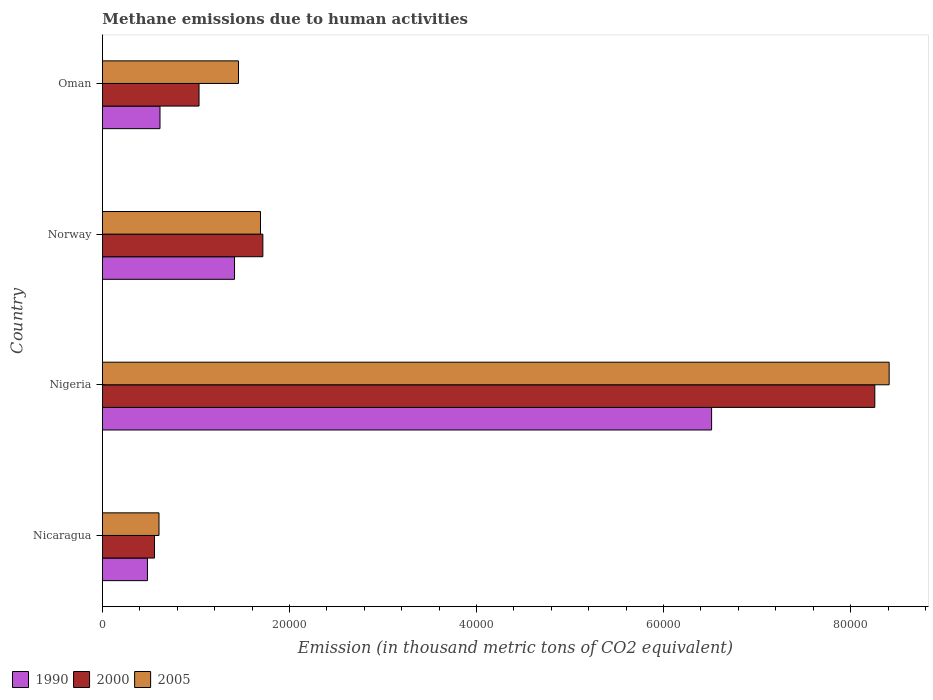How many different coloured bars are there?
Your answer should be compact. 3. How many groups of bars are there?
Give a very brief answer. 4. Are the number of bars per tick equal to the number of legend labels?
Offer a very short reply. Yes. Are the number of bars on each tick of the Y-axis equal?
Your answer should be compact. Yes. How many bars are there on the 2nd tick from the bottom?
Your answer should be compact. 3. What is the label of the 3rd group of bars from the top?
Your response must be concise. Nigeria. In how many cases, is the number of bars for a given country not equal to the number of legend labels?
Provide a short and direct response. 0. What is the amount of methane emitted in 2000 in Oman?
Offer a terse response. 1.03e+04. Across all countries, what is the maximum amount of methane emitted in 1990?
Keep it short and to the point. 6.51e+04. Across all countries, what is the minimum amount of methane emitted in 2000?
Provide a succinct answer. 5565.7. In which country was the amount of methane emitted in 2005 maximum?
Provide a short and direct response. Nigeria. In which country was the amount of methane emitted in 2005 minimum?
Offer a very short reply. Nicaragua. What is the total amount of methane emitted in 2000 in the graph?
Your answer should be very brief. 1.16e+05. What is the difference between the amount of methane emitted in 2005 in Nicaragua and that in Norway?
Make the answer very short. -1.09e+04. What is the difference between the amount of methane emitted in 1990 in Norway and the amount of methane emitted in 2000 in Oman?
Your response must be concise. 3795.6. What is the average amount of methane emitted in 2005 per country?
Offer a terse response. 3.04e+04. What is the difference between the amount of methane emitted in 1990 and amount of methane emitted in 2005 in Nicaragua?
Ensure brevity in your answer.  -1233.7. What is the ratio of the amount of methane emitted in 1990 in Nicaragua to that in Oman?
Your answer should be very brief. 0.78. Is the amount of methane emitted in 2000 in Norway less than that in Oman?
Your response must be concise. No. Is the difference between the amount of methane emitted in 1990 in Norway and Oman greater than the difference between the amount of methane emitted in 2005 in Norway and Oman?
Give a very brief answer. Yes. What is the difference between the highest and the second highest amount of methane emitted in 2000?
Provide a short and direct response. 6.54e+04. What is the difference between the highest and the lowest amount of methane emitted in 2005?
Ensure brevity in your answer.  7.81e+04. In how many countries, is the amount of methane emitted in 1990 greater than the average amount of methane emitted in 1990 taken over all countries?
Provide a succinct answer. 1. Is the sum of the amount of methane emitted in 2005 in Nicaragua and Nigeria greater than the maximum amount of methane emitted in 1990 across all countries?
Provide a succinct answer. Yes. What does the 3rd bar from the top in Oman represents?
Your response must be concise. 1990. What does the 1st bar from the bottom in Norway represents?
Provide a short and direct response. 1990. Are all the bars in the graph horizontal?
Your answer should be very brief. Yes. How many countries are there in the graph?
Keep it short and to the point. 4. Are the values on the major ticks of X-axis written in scientific E-notation?
Offer a very short reply. No. Does the graph contain any zero values?
Keep it short and to the point. No. How many legend labels are there?
Offer a very short reply. 3. How are the legend labels stacked?
Give a very brief answer. Horizontal. What is the title of the graph?
Keep it short and to the point. Methane emissions due to human activities. Does "1998" appear as one of the legend labels in the graph?
Your answer should be very brief. No. What is the label or title of the X-axis?
Offer a very short reply. Emission (in thousand metric tons of CO2 equivalent). What is the Emission (in thousand metric tons of CO2 equivalent) in 1990 in Nicaragua?
Ensure brevity in your answer.  4811.3. What is the Emission (in thousand metric tons of CO2 equivalent) in 2000 in Nicaragua?
Keep it short and to the point. 5565.7. What is the Emission (in thousand metric tons of CO2 equivalent) of 2005 in Nicaragua?
Give a very brief answer. 6045. What is the Emission (in thousand metric tons of CO2 equivalent) in 1990 in Nigeria?
Your answer should be compact. 6.51e+04. What is the Emission (in thousand metric tons of CO2 equivalent) in 2000 in Nigeria?
Make the answer very short. 8.26e+04. What is the Emission (in thousand metric tons of CO2 equivalent) in 2005 in Nigeria?
Ensure brevity in your answer.  8.41e+04. What is the Emission (in thousand metric tons of CO2 equivalent) in 1990 in Norway?
Your answer should be very brief. 1.41e+04. What is the Emission (in thousand metric tons of CO2 equivalent) in 2000 in Norway?
Your answer should be compact. 1.72e+04. What is the Emission (in thousand metric tons of CO2 equivalent) in 2005 in Norway?
Provide a short and direct response. 1.69e+04. What is the Emission (in thousand metric tons of CO2 equivalent) in 1990 in Oman?
Ensure brevity in your answer.  6152.9. What is the Emission (in thousand metric tons of CO2 equivalent) in 2000 in Oman?
Provide a short and direct response. 1.03e+04. What is the Emission (in thousand metric tons of CO2 equivalent) of 2005 in Oman?
Your response must be concise. 1.45e+04. Across all countries, what is the maximum Emission (in thousand metric tons of CO2 equivalent) of 1990?
Keep it short and to the point. 6.51e+04. Across all countries, what is the maximum Emission (in thousand metric tons of CO2 equivalent) in 2000?
Give a very brief answer. 8.26e+04. Across all countries, what is the maximum Emission (in thousand metric tons of CO2 equivalent) of 2005?
Provide a succinct answer. 8.41e+04. Across all countries, what is the minimum Emission (in thousand metric tons of CO2 equivalent) of 1990?
Offer a terse response. 4811.3. Across all countries, what is the minimum Emission (in thousand metric tons of CO2 equivalent) of 2000?
Make the answer very short. 5565.7. Across all countries, what is the minimum Emission (in thousand metric tons of CO2 equivalent) of 2005?
Offer a very short reply. 6045. What is the total Emission (in thousand metric tons of CO2 equivalent) in 1990 in the graph?
Your answer should be very brief. 9.02e+04. What is the total Emission (in thousand metric tons of CO2 equivalent) in 2000 in the graph?
Your answer should be very brief. 1.16e+05. What is the total Emission (in thousand metric tons of CO2 equivalent) in 2005 in the graph?
Your answer should be compact. 1.22e+05. What is the difference between the Emission (in thousand metric tons of CO2 equivalent) of 1990 in Nicaragua and that in Nigeria?
Your answer should be very brief. -6.03e+04. What is the difference between the Emission (in thousand metric tons of CO2 equivalent) of 2000 in Nicaragua and that in Nigeria?
Ensure brevity in your answer.  -7.70e+04. What is the difference between the Emission (in thousand metric tons of CO2 equivalent) in 2005 in Nicaragua and that in Nigeria?
Provide a succinct answer. -7.81e+04. What is the difference between the Emission (in thousand metric tons of CO2 equivalent) of 1990 in Nicaragua and that in Norway?
Your response must be concise. -9310.6. What is the difference between the Emission (in thousand metric tons of CO2 equivalent) in 2000 in Nicaragua and that in Norway?
Your response must be concise. -1.16e+04. What is the difference between the Emission (in thousand metric tons of CO2 equivalent) in 2005 in Nicaragua and that in Norway?
Ensure brevity in your answer.  -1.09e+04. What is the difference between the Emission (in thousand metric tons of CO2 equivalent) in 1990 in Nicaragua and that in Oman?
Provide a succinct answer. -1341.6. What is the difference between the Emission (in thousand metric tons of CO2 equivalent) of 2000 in Nicaragua and that in Oman?
Your response must be concise. -4760.6. What is the difference between the Emission (in thousand metric tons of CO2 equivalent) of 2005 in Nicaragua and that in Oman?
Ensure brevity in your answer.  -8501.1. What is the difference between the Emission (in thousand metric tons of CO2 equivalent) in 1990 in Nigeria and that in Norway?
Provide a succinct answer. 5.10e+04. What is the difference between the Emission (in thousand metric tons of CO2 equivalent) of 2000 in Nigeria and that in Norway?
Offer a very short reply. 6.54e+04. What is the difference between the Emission (in thousand metric tons of CO2 equivalent) of 2005 in Nigeria and that in Norway?
Ensure brevity in your answer.  6.72e+04. What is the difference between the Emission (in thousand metric tons of CO2 equivalent) of 1990 in Nigeria and that in Oman?
Make the answer very short. 5.90e+04. What is the difference between the Emission (in thousand metric tons of CO2 equivalent) in 2000 in Nigeria and that in Oman?
Give a very brief answer. 7.23e+04. What is the difference between the Emission (in thousand metric tons of CO2 equivalent) of 2005 in Nigeria and that in Oman?
Provide a short and direct response. 6.96e+04. What is the difference between the Emission (in thousand metric tons of CO2 equivalent) of 1990 in Norway and that in Oman?
Give a very brief answer. 7969. What is the difference between the Emission (in thousand metric tons of CO2 equivalent) of 2000 in Norway and that in Oman?
Your answer should be very brief. 6825.4. What is the difference between the Emission (in thousand metric tons of CO2 equivalent) in 2005 in Norway and that in Oman?
Your answer should be very brief. 2350.8. What is the difference between the Emission (in thousand metric tons of CO2 equivalent) in 1990 in Nicaragua and the Emission (in thousand metric tons of CO2 equivalent) in 2000 in Nigeria?
Provide a succinct answer. -7.78e+04. What is the difference between the Emission (in thousand metric tons of CO2 equivalent) of 1990 in Nicaragua and the Emission (in thousand metric tons of CO2 equivalent) of 2005 in Nigeria?
Offer a terse response. -7.93e+04. What is the difference between the Emission (in thousand metric tons of CO2 equivalent) of 2000 in Nicaragua and the Emission (in thousand metric tons of CO2 equivalent) of 2005 in Nigeria?
Your answer should be compact. -7.86e+04. What is the difference between the Emission (in thousand metric tons of CO2 equivalent) of 1990 in Nicaragua and the Emission (in thousand metric tons of CO2 equivalent) of 2000 in Norway?
Give a very brief answer. -1.23e+04. What is the difference between the Emission (in thousand metric tons of CO2 equivalent) of 1990 in Nicaragua and the Emission (in thousand metric tons of CO2 equivalent) of 2005 in Norway?
Provide a succinct answer. -1.21e+04. What is the difference between the Emission (in thousand metric tons of CO2 equivalent) of 2000 in Nicaragua and the Emission (in thousand metric tons of CO2 equivalent) of 2005 in Norway?
Your answer should be very brief. -1.13e+04. What is the difference between the Emission (in thousand metric tons of CO2 equivalent) in 1990 in Nicaragua and the Emission (in thousand metric tons of CO2 equivalent) in 2000 in Oman?
Give a very brief answer. -5515. What is the difference between the Emission (in thousand metric tons of CO2 equivalent) in 1990 in Nicaragua and the Emission (in thousand metric tons of CO2 equivalent) in 2005 in Oman?
Ensure brevity in your answer.  -9734.8. What is the difference between the Emission (in thousand metric tons of CO2 equivalent) in 2000 in Nicaragua and the Emission (in thousand metric tons of CO2 equivalent) in 2005 in Oman?
Your answer should be compact. -8980.4. What is the difference between the Emission (in thousand metric tons of CO2 equivalent) in 1990 in Nigeria and the Emission (in thousand metric tons of CO2 equivalent) in 2000 in Norway?
Your response must be concise. 4.80e+04. What is the difference between the Emission (in thousand metric tons of CO2 equivalent) in 1990 in Nigeria and the Emission (in thousand metric tons of CO2 equivalent) in 2005 in Norway?
Provide a short and direct response. 4.82e+04. What is the difference between the Emission (in thousand metric tons of CO2 equivalent) in 2000 in Nigeria and the Emission (in thousand metric tons of CO2 equivalent) in 2005 in Norway?
Provide a short and direct response. 6.57e+04. What is the difference between the Emission (in thousand metric tons of CO2 equivalent) in 1990 in Nigeria and the Emission (in thousand metric tons of CO2 equivalent) in 2000 in Oman?
Make the answer very short. 5.48e+04. What is the difference between the Emission (in thousand metric tons of CO2 equivalent) of 1990 in Nigeria and the Emission (in thousand metric tons of CO2 equivalent) of 2005 in Oman?
Your response must be concise. 5.06e+04. What is the difference between the Emission (in thousand metric tons of CO2 equivalent) of 2000 in Nigeria and the Emission (in thousand metric tons of CO2 equivalent) of 2005 in Oman?
Offer a very short reply. 6.80e+04. What is the difference between the Emission (in thousand metric tons of CO2 equivalent) of 1990 in Norway and the Emission (in thousand metric tons of CO2 equivalent) of 2000 in Oman?
Your answer should be compact. 3795.6. What is the difference between the Emission (in thousand metric tons of CO2 equivalent) of 1990 in Norway and the Emission (in thousand metric tons of CO2 equivalent) of 2005 in Oman?
Make the answer very short. -424.2. What is the difference between the Emission (in thousand metric tons of CO2 equivalent) in 2000 in Norway and the Emission (in thousand metric tons of CO2 equivalent) in 2005 in Oman?
Provide a succinct answer. 2605.6. What is the average Emission (in thousand metric tons of CO2 equivalent) in 1990 per country?
Offer a very short reply. 2.26e+04. What is the average Emission (in thousand metric tons of CO2 equivalent) in 2000 per country?
Your answer should be compact. 2.89e+04. What is the average Emission (in thousand metric tons of CO2 equivalent) in 2005 per country?
Give a very brief answer. 3.04e+04. What is the difference between the Emission (in thousand metric tons of CO2 equivalent) in 1990 and Emission (in thousand metric tons of CO2 equivalent) in 2000 in Nicaragua?
Provide a short and direct response. -754.4. What is the difference between the Emission (in thousand metric tons of CO2 equivalent) of 1990 and Emission (in thousand metric tons of CO2 equivalent) of 2005 in Nicaragua?
Your answer should be very brief. -1233.7. What is the difference between the Emission (in thousand metric tons of CO2 equivalent) of 2000 and Emission (in thousand metric tons of CO2 equivalent) of 2005 in Nicaragua?
Offer a terse response. -479.3. What is the difference between the Emission (in thousand metric tons of CO2 equivalent) of 1990 and Emission (in thousand metric tons of CO2 equivalent) of 2000 in Nigeria?
Your response must be concise. -1.75e+04. What is the difference between the Emission (in thousand metric tons of CO2 equivalent) of 1990 and Emission (in thousand metric tons of CO2 equivalent) of 2005 in Nigeria?
Offer a very short reply. -1.90e+04. What is the difference between the Emission (in thousand metric tons of CO2 equivalent) of 2000 and Emission (in thousand metric tons of CO2 equivalent) of 2005 in Nigeria?
Offer a terse response. -1533.6. What is the difference between the Emission (in thousand metric tons of CO2 equivalent) in 1990 and Emission (in thousand metric tons of CO2 equivalent) in 2000 in Norway?
Your answer should be compact. -3029.8. What is the difference between the Emission (in thousand metric tons of CO2 equivalent) of 1990 and Emission (in thousand metric tons of CO2 equivalent) of 2005 in Norway?
Ensure brevity in your answer.  -2775. What is the difference between the Emission (in thousand metric tons of CO2 equivalent) in 2000 and Emission (in thousand metric tons of CO2 equivalent) in 2005 in Norway?
Keep it short and to the point. 254.8. What is the difference between the Emission (in thousand metric tons of CO2 equivalent) in 1990 and Emission (in thousand metric tons of CO2 equivalent) in 2000 in Oman?
Offer a terse response. -4173.4. What is the difference between the Emission (in thousand metric tons of CO2 equivalent) in 1990 and Emission (in thousand metric tons of CO2 equivalent) in 2005 in Oman?
Your response must be concise. -8393.2. What is the difference between the Emission (in thousand metric tons of CO2 equivalent) in 2000 and Emission (in thousand metric tons of CO2 equivalent) in 2005 in Oman?
Keep it short and to the point. -4219.8. What is the ratio of the Emission (in thousand metric tons of CO2 equivalent) of 1990 in Nicaragua to that in Nigeria?
Give a very brief answer. 0.07. What is the ratio of the Emission (in thousand metric tons of CO2 equivalent) in 2000 in Nicaragua to that in Nigeria?
Offer a terse response. 0.07. What is the ratio of the Emission (in thousand metric tons of CO2 equivalent) in 2005 in Nicaragua to that in Nigeria?
Ensure brevity in your answer.  0.07. What is the ratio of the Emission (in thousand metric tons of CO2 equivalent) in 1990 in Nicaragua to that in Norway?
Your answer should be very brief. 0.34. What is the ratio of the Emission (in thousand metric tons of CO2 equivalent) of 2000 in Nicaragua to that in Norway?
Make the answer very short. 0.32. What is the ratio of the Emission (in thousand metric tons of CO2 equivalent) in 2005 in Nicaragua to that in Norway?
Ensure brevity in your answer.  0.36. What is the ratio of the Emission (in thousand metric tons of CO2 equivalent) of 1990 in Nicaragua to that in Oman?
Your answer should be compact. 0.78. What is the ratio of the Emission (in thousand metric tons of CO2 equivalent) in 2000 in Nicaragua to that in Oman?
Offer a very short reply. 0.54. What is the ratio of the Emission (in thousand metric tons of CO2 equivalent) of 2005 in Nicaragua to that in Oman?
Keep it short and to the point. 0.42. What is the ratio of the Emission (in thousand metric tons of CO2 equivalent) of 1990 in Nigeria to that in Norway?
Your answer should be compact. 4.61. What is the ratio of the Emission (in thousand metric tons of CO2 equivalent) of 2000 in Nigeria to that in Norway?
Provide a short and direct response. 4.82. What is the ratio of the Emission (in thousand metric tons of CO2 equivalent) in 2005 in Nigeria to that in Norway?
Your response must be concise. 4.98. What is the ratio of the Emission (in thousand metric tons of CO2 equivalent) of 1990 in Nigeria to that in Oman?
Ensure brevity in your answer.  10.59. What is the ratio of the Emission (in thousand metric tons of CO2 equivalent) in 2000 in Nigeria to that in Oman?
Offer a terse response. 8. What is the ratio of the Emission (in thousand metric tons of CO2 equivalent) in 2005 in Nigeria to that in Oman?
Your answer should be compact. 5.78. What is the ratio of the Emission (in thousand metric tons of CO2 equivalent) in 1990 in Norway to that in Oman?
Keep it short and to the point. 2.3. What is the ratio of the Emission (in thousand metric tons of CO2 equivalent) of 2000 in Norway to that in Oman?
Your answer should be very brief. 1.66. What is the ratio of the Emission (in thousand metric tons of CO2 equivalent) in 2005 in Norway to that in Oman?
Make the answer very short. 1.16. What is the difference between the highest and the second highest Emission (in thousand metric tons of CO2 equivalent) of 1990?
Offer a terse response. 5.10e+04. What is the difference between the highest and the second highest Emission (in thousand metric tons of CO2 equivalent) of 2000?
Ensure brevity in your answer.  6.54e+04. What is the difference between the highest and the second highest Emission (in thousand metric tons of CO2 equivalent) in 2005?
Give a very brief answer. 6.72e+04. What is the difference between the highest and the lowest Emission (in thousand metric tons of CO2 equivalent) of 1990?
Give a very brief answer. 6.03e+04. What is the difference between the highest and the lowest Emission (in thousand metric tons of CO2 equivalent) in 2000?
Give a very brief answer. 7.70e+04. What is the difference between the highest and the lowest Emission (in thousand metric tons of CO2 equivalent) of 2005?
Your response must be concise. 7.81e+04. 